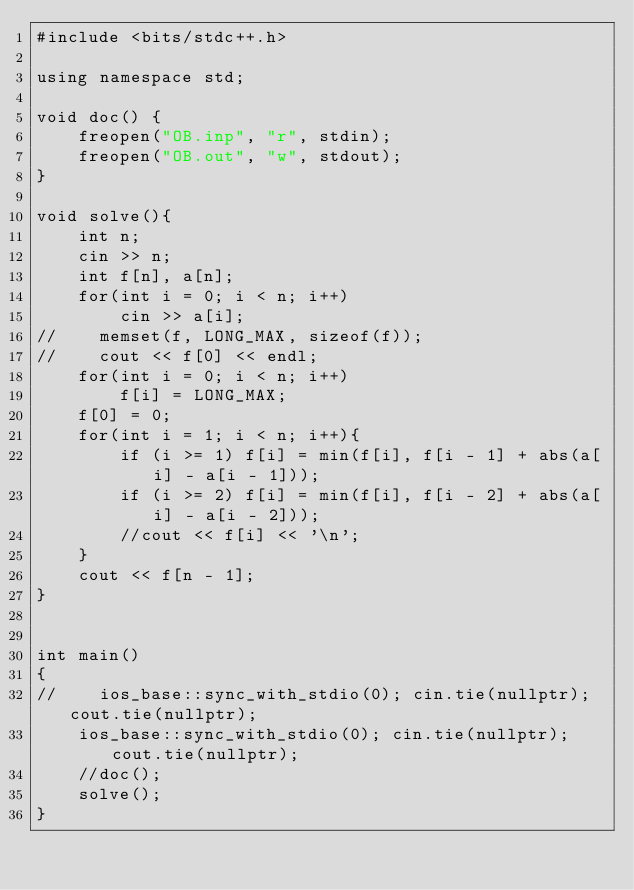<code> <loc_0><loc_0><loc_500><loc_500><_C++_>#include <bits/stdc++.h>

using namespace std;

void doc() {
    freopen("OB.inp", "r", stdin);
    freopen("OB.out", "w", stdout);
}

void solve(){
    int n;
    cin >> n;
    int f[n], a[n];
    for(int i = 0; i < n; i++)
        cin >> a[i];
//    memset(f, LONG_MAX, sizeof(f));
//    cout << f[0] << endl;
    for(int i = 0; i < n; i++)
        f[i] = LONG_MAX;
    f[0] = 0;
    for(int i = 1; i < n; i++){
        if (i >= 1) f[i] = min(f[i], f[i - 1] + abs(a[i] - a[i - 1]));
        if (i >= 2) f[i] = min(f[i], f[i - 2] + abs(a[i] - a[i - 2]));
        //cout << f[i] << '\n';
    }
    cout << f[n - 1];
}


int main()
{
//    ios_base::sync_with_stdio(0); cin.tie(nullptr); cout.tie(nullptr);
    ios_base::sync_with_stdio(0); cin.tie(nullptr); cout.tie(nullptr);
    //doc();
    solve();
}

</code> 